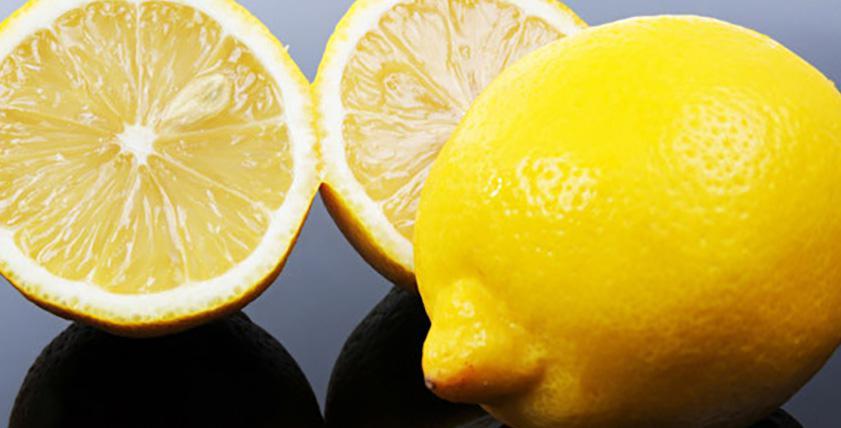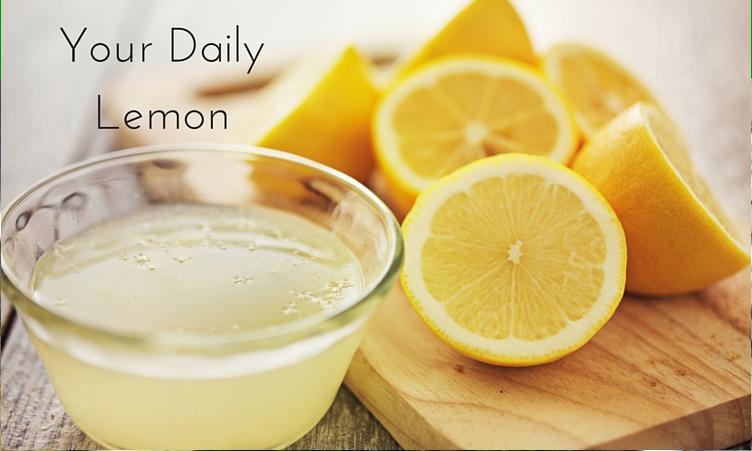The first image is the image on the left, the second image is the image on the right. For the images shown, is this caption "The combined images include cut and whole lemons and a clear glass containing citrus juice." true? Answer yes or no. Yes. The first image is the image on the left, the second image is the image on the right. Given the left and right images, does the statement "There are only whole lemons in one of the images." hold true? Answer yes or no. No. 